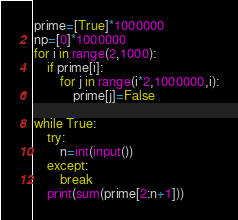Convert code to text. <code><loc_0><loc_0><loc_500><loc_500><_Python_>prime=[True]*1000000
np=[0]*1000000
for i in range(2,1000):
    if prime[i]:
        for j in range(i*2,1000000,i):
            prime[j]=False

while True:
    try:
        n=int(input())
    except:
        break
    print(sum(prime[2:n+1]))</code> 